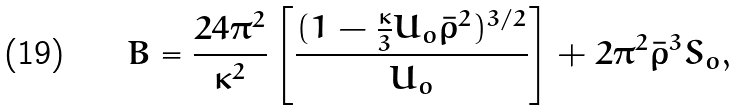Convert formula to latex. <formula><loc_0><loc_0><loc_500><loc_500>B = \frac { 2 4 \pi ^ { 2 } } { \kappa ^ { 2 } } \left [ \frac { ( 1 - \frac { \kappa } { 3 } U _ { o } \bar { \rho } ^ { 2 } ) ^ { 3 / 2 } } { U _ { o } } \right ] + 2 \pi ^ { 2 } \bar { \rho } ^ { 3 } S _ { o } ,</formula> 